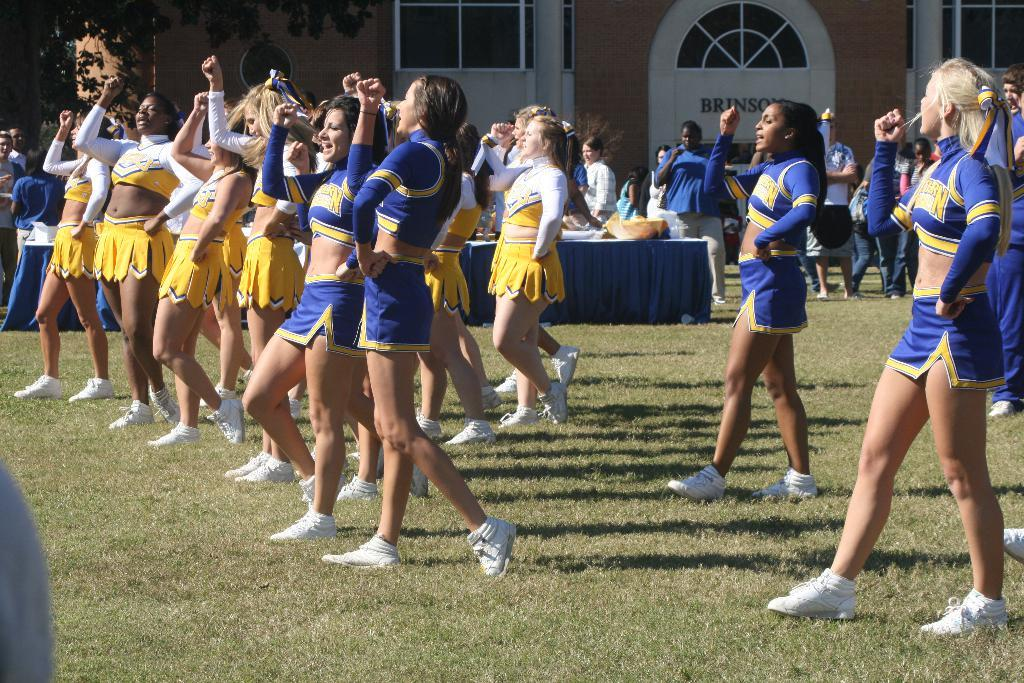<image>
Offer a succinct explanation of the picture presented. Cheerleaders from northern are wearing blue outfits on a field. 